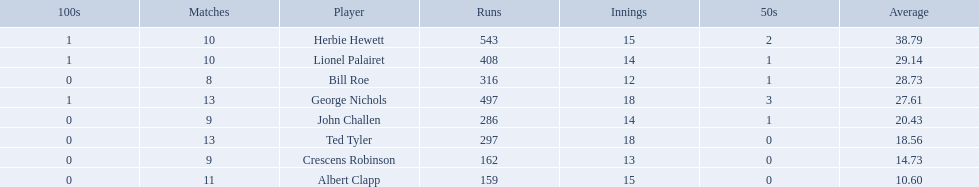Could you help me parse every detail presented in this table? {'header': ['100s', 'Matches', 'Player', 'Runs', 'Innings', '50s', 'Average'], 'rows': [['1', '10', 'Herbie Hewett', '543', '15', '2', '38.79'], ['1', '10', 'Lionel Palairet', '408', '14', '1', '29.14'], ['0', '8', 'Bill Roe', '316', '12', '1', '28.73'], ['1', '13', 'George Nichols', '497', '18', '3', '27.61'], ['0', '9', 'John Challen', '286', '14', '1', '20.43'], ['0', '13', 'Ted Tyler', '297', '18', '0', '18.56'], ['0', '9', 'Crescens Robinson', '162', '13', '0', '14.73'], ['0', '11', 'Albert Clapp', '159', '15', '0', '10.60']]} Who are all of the players? Herbie Hewett, Lionel Palairet, Bill Roe, George Nichols, John Challen, Ted Tyler, Crescens Robinson, Albert Clapp. How many innings did they play in? 15, 14, 12, 18, 14, 18, 13, 15. Which player was in fewer than 13 innings? Bill Roe. 